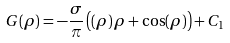<formula> <loc_0><loc_0><loc_500><loc_500>G ( \rho ) = - \frac { \sigma } { \pi } \left ( ( \rho ) \, \rho + \cos ( \rho ) \right ) + C _ { 1 }</formula> 